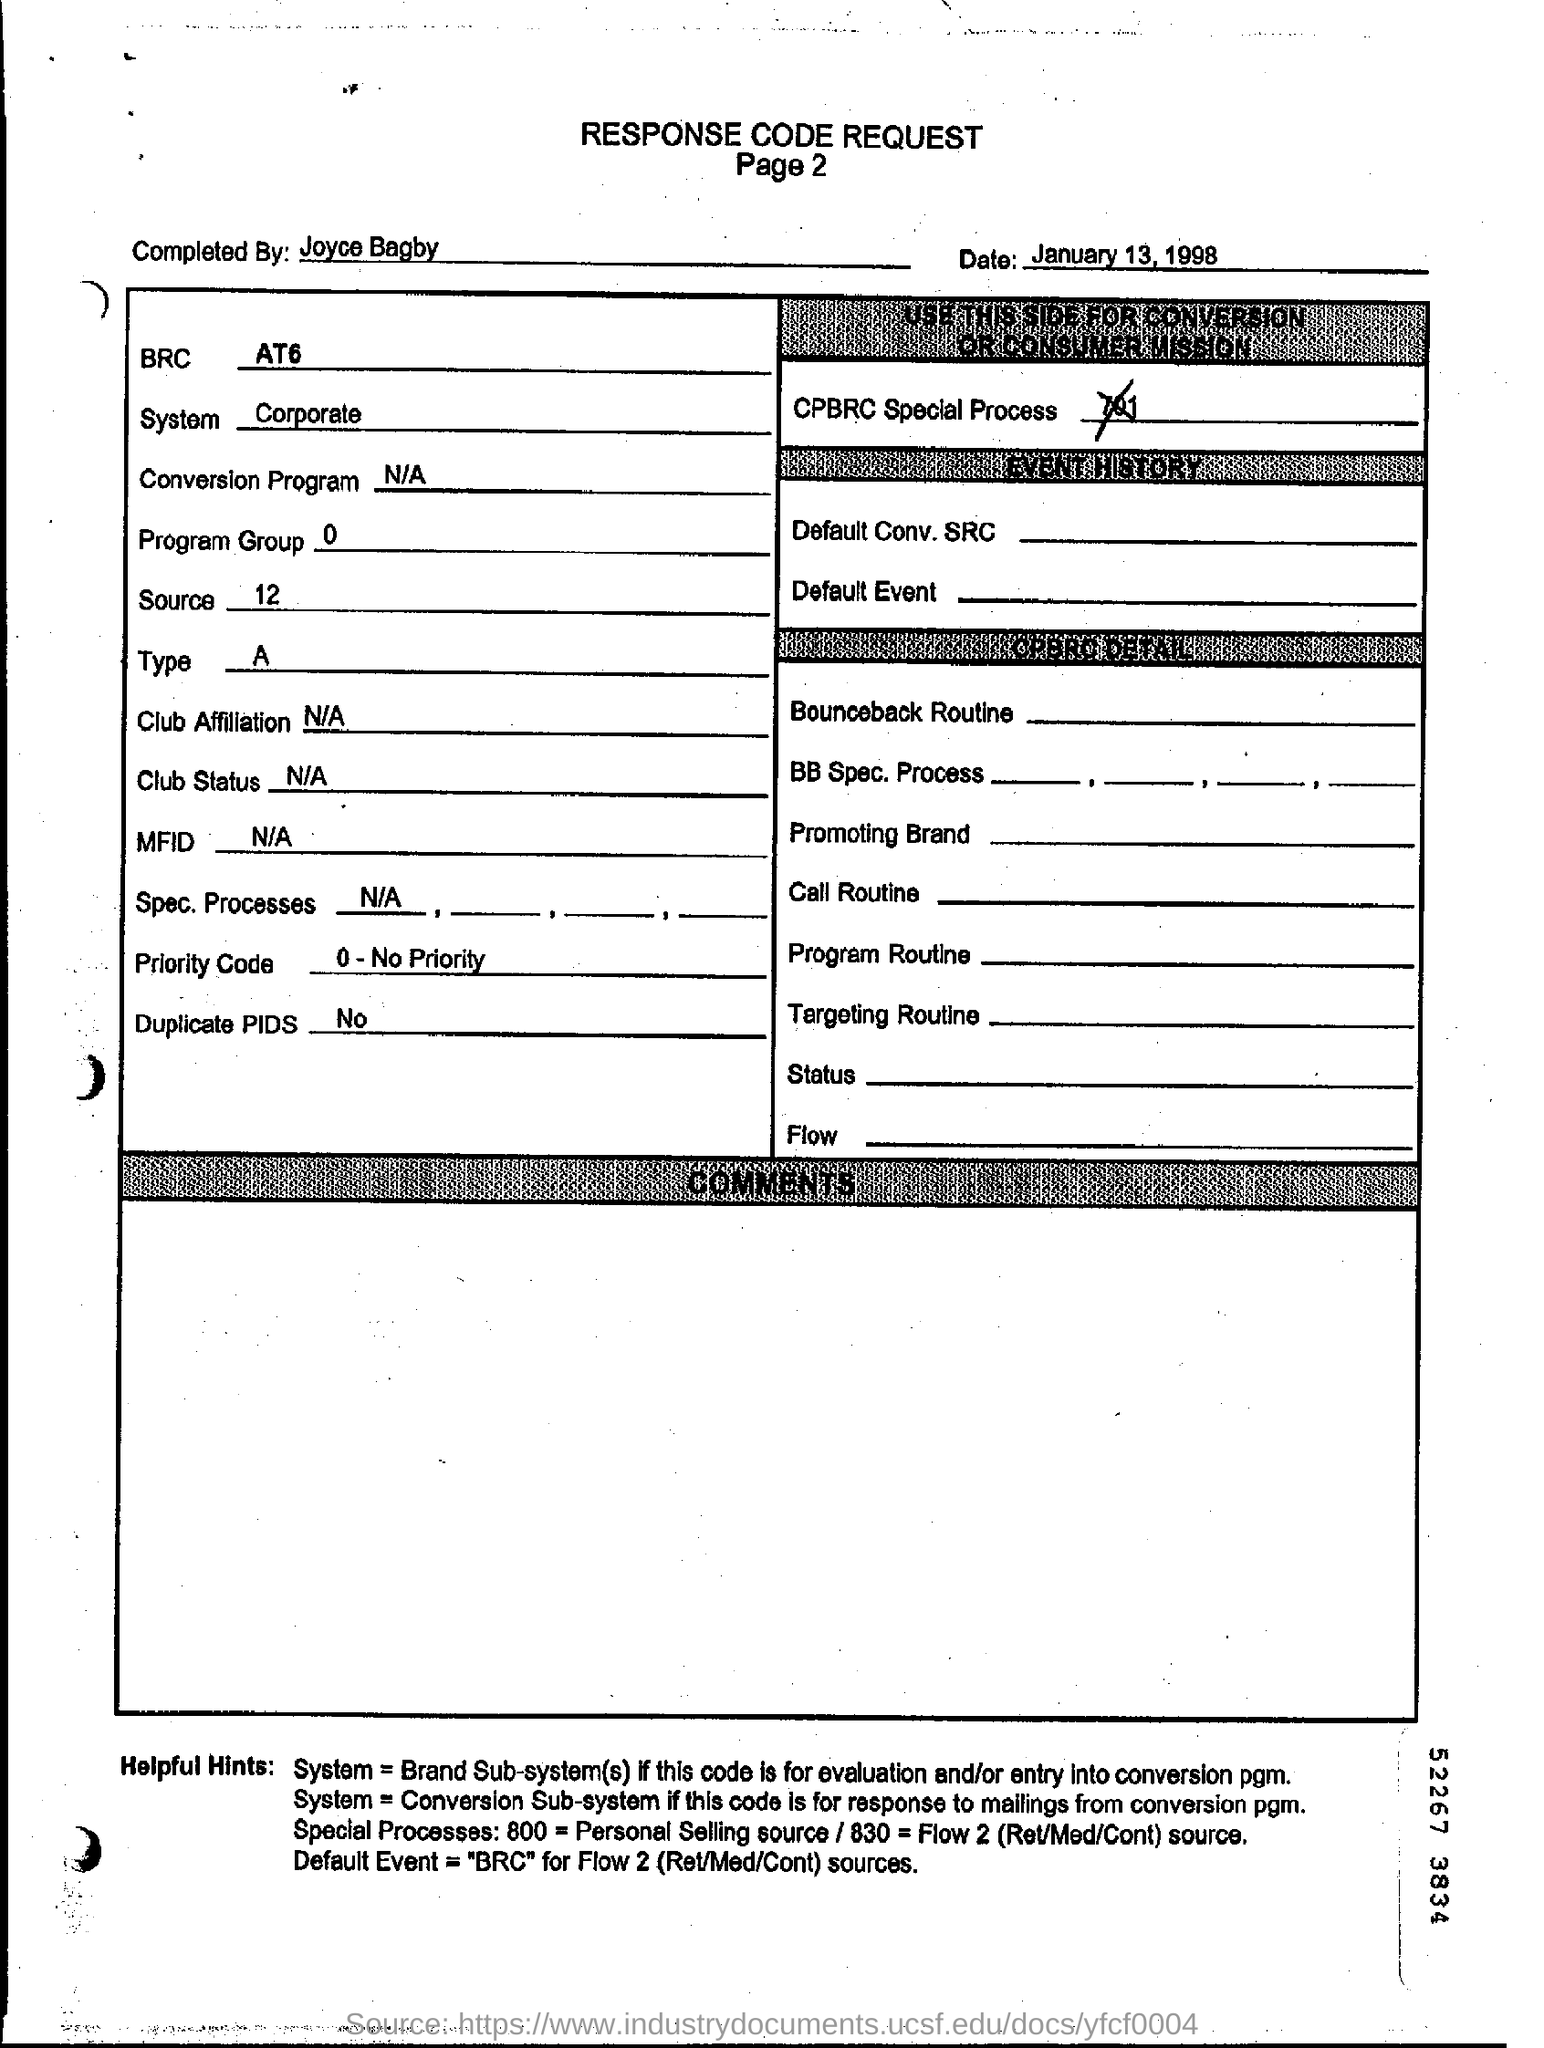What is written in top of the document ?
Make the answer very short. RESPONSE CODE REQUEST. What is written below the main Heading of the document ?
Give a very brief answer. Page 2. What is the date mentioned in the top of the document ?
Offer a terse response. January 13, 1998. What is the Priority code ?
Ensure brevity in your answer.  0-No Priority. What is the Club Status ?
Offer a very short reply. N/A. What is the Source Number ?
Give a very brief answer. 12. What is the Program Group ?
Offer a very short reply. 0. Who filled this form?
Provide a succinct answer. Joyce Bagby. 